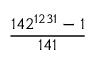<formula> <loc_0><loc_0><loc_500><loc_500>\frac { 1 4 2 ^ { 1 2 3 1 } - 1 } { 1 4 1 }</formula> 